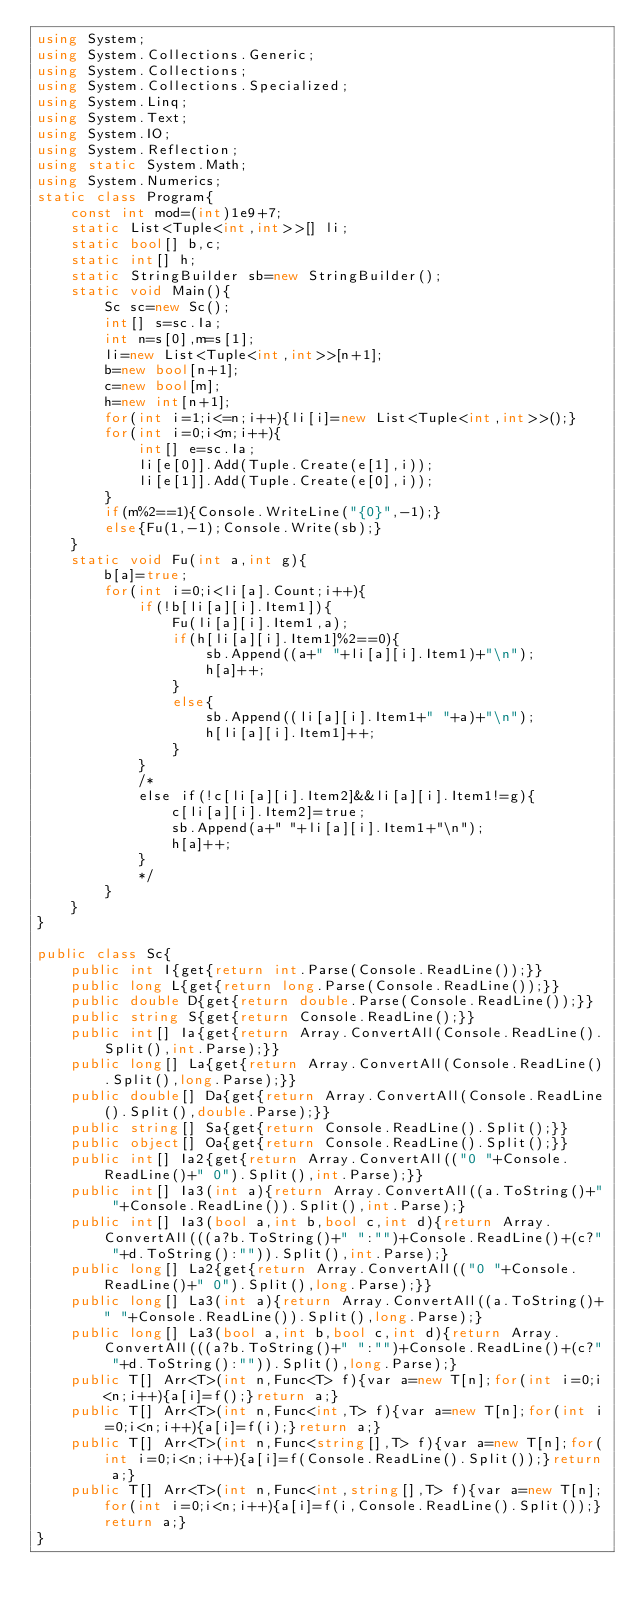Convert code to text. <code><loc_0><loc_0><loc_500><loc_500><_C#_>using System;
using System.Collections.Generic;
using System.Collections;
using System.Collections.Specialized;
using System.Linq;
using System.Text;
using System.IO;
using System.Reflection;
using static System.Math;
using System.Numerics;
static class Program{
	const int mod=(int)1e9+7;
	static List<Tuple<int,int>>[] li;
	static bool[] b,c;
	static int[] h;
	static StringBuilder sb=new StringBuilder();
	static void Main(){
		Sc sc=new Sc();
		int[] s=sc.Ia;
		int n=s[0],m=s[1];
		li=new List<Tuple<int,int>>[n+1];
		b=new bool[n+1];
		c=new bool[m];
		h=new int[n+1];
		for(int i=1;i<=n;i++){li[i]=new List<Tuple<int,int>>();}
		for(int i=0;i<m;i++){
			int[] e=sc.Ia;
			li[e[0]].Add(Tuple.Create(e[1],i));
			li[e[1]].Add(Tuple.Create(e[0],i));
		}
		if(m%2==1){Console.WriteLine("{0}",-1);}
		else{Fu(1,-1);Console.Write(sb);}
	}
	static void Fu(int a,int g){
		b[a]=true;
		for(int i=0;i<li[a].Count;i++){
			if(!b[li[a][i].Item1]){
				Fu(li[a][i].Item1,a);
				if(h[li[a][i].Item1]%2==0){
					sb.Append((a+" "+li[a][i].Item1)+"\n");
					h[a]++;
				}
				else{
					sb.Append((li[a][i].Item1+" "+a)+"\n");
					h[li[a][i].Item1]++;
				}
			}
			/*
			else if(!c[li[a][i].Item2]&&li[a][i].Item1!=g){
				c[li[a][i].Item2]=true;
				sb.Append(a+" "+li[a][i].Item1+"\n");
				h[a]++;
			}
			*/
		}
	}
}

public class Sc{
	public int I{get{return int.Parse(Console.ReadLine());}}
	public long L{get{return long.Parse(Console.ReadLine());}}
	public double D{get{return double.Parse(Console.ReadLine());}}
	public string S{get{return Console.ReadLine();}}
	public int[] Ia{get{return Array.ConvertAll(Console.ReadLine().Split(),int.Parse);}}
	public long[] La{get{return Array.ConvertAll(Console.ReadLine().Split(),long.Parse);}}
	public double[] Da{get{return Array.ConvertAll(Console.ReadLine().Split(),double.Parse);}}
	public string[] Sa{get{return Console.ReadLine().Split();}}
	public object[] Oa{get{return Console.ReadLine().Split();}}
	public int[] Ia2{get{return Array.ConvertAll(("0 "+Console.ReadLine()+" 0").Split(),int.Parse);}}
	public int[] Ia3(int a){return Array.ConvertAll((a.ToString()+" "+Console.ReadLine()).Split(),int.Parse);}
	public int[] Ia3(bool a,int b,bool c,int d){return Array.ConvertAll(((a?b.ToString()+" ":"")+Console.ReadLine()+(c?" "+d.ToString():"")).Split(),int.Parse);}
	public long[] La2{get{return Array.ConvertAll(("0 "+Console.ReadLine()+" 0").Split(),long.Parse);}}
	public long[] La3(int a){return Array.ConvertAll((a.ToString()+" "+Console.ReadLine()).Split(),long.Parse);}
	public long[] La3(bool a,int b,bool c,int d){return Array.ConvertAll(((a?b.ToString()+" ":"")+Console.ReadLine()+(c?" "+d.ToString():"")).Split(),long.Parse);}
	public T[] Arr<T>(int n,Func<T> f){var a=new T[n];for(int i=0;i<n;i++){a[i]=f();}return a;}
	public T[] Arr<T>(int n,Func<int,T> f){var a=new T[n];for(int i=0;i<n;i++){a[i]=f(i);}return a;}
	public T[] Arr<T>(int n,Func<string[],T> f){var a=new T[n];for(int i=0;i<n;i++){a[i]=f(Console.ReadLine().Split());}return a;}
	public T[] Arr<T>(int n,Func<int,string[],T> f){var a=new T[n];for(int i=0;i<n;i++){a[i]=f(i,Console.ReadLine().Split());}return a;}
}
</code> 